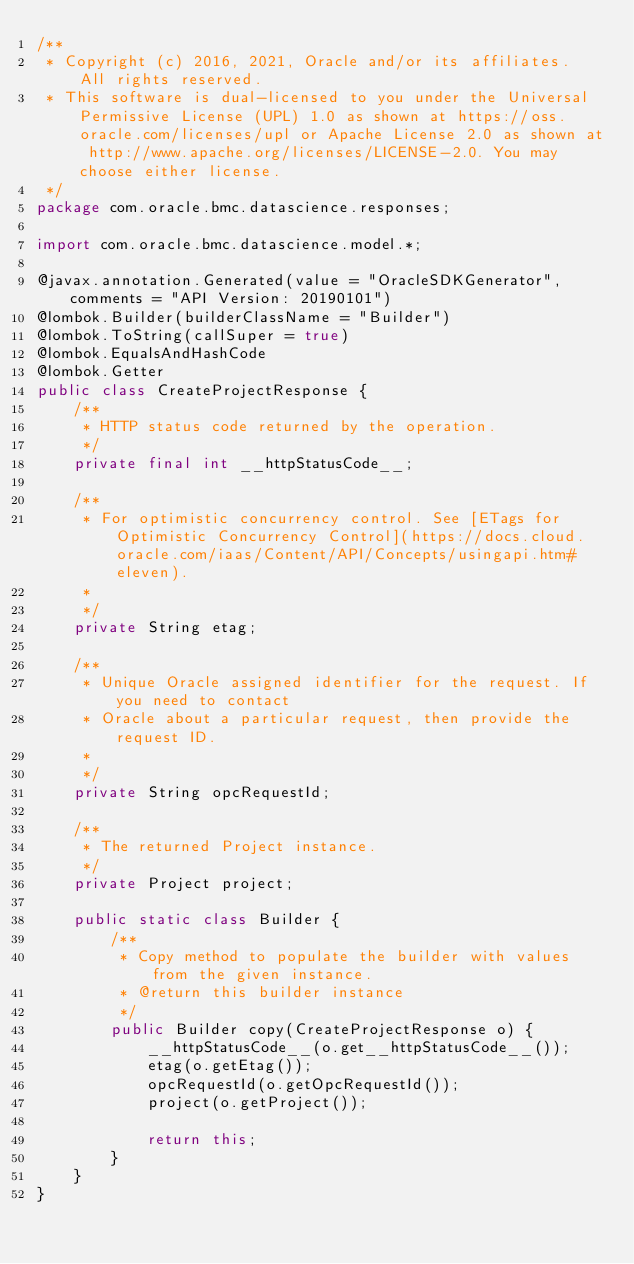<code> <loc_0><loc_0><loc_500><loc_500><_Java_>/**
 * Copyright (c) 2016, 2021, Oracle and/or its affiliates.  All rights reserved.
 * This software is dual-licensed to you under the Universal Permissive License (UPL) 1.0 as shown at https://oss.oracle.com/licenses/upl or Apache License 2.0 as shown at http://www.apache.org/licenses/LICENSE-2.0. You may choose either license.
 */
package com.oracle.bmc.datascience.responses;

import com.oracle.bmc.datascience.model.*;

@javax.annotation.Generated(value = "OracleSDKGenerator", comments = "API Version: 20190101")
@lombok.Builder(builderClassName = "Builder")
@lombok.ToString(callSuper = true)
@lombok.EqualsAndHashCode
@lombok.Getter
public class CreateProjectResponse {
    /**
     * HTTP status code returned by the operation.
     */
    private final int __httpStatusCode__;

    /**
     * For optimistic concurrency control. See [ETags for Optimistic Concurrency Control](https://docs.cloud.oracle.com/iaas/Content/API/Concepts/usingapi.htm#eleven).
     *
     */
    private String etag;

    /**
     * Unique Oracle assigned identifier for the request. If you need to contact
     * Oracle about a particular request, then provide the request ID.
     *
     */
    private String opcRequestId;

    /**
     * The returned Project instance.
     */
    private Project project;

    public static class Builder {
        /**
         * Copy method to populate the builder with values from the given instance.
         * @return this builder instance
         */
        public Builder copy(CreateProjectResponse o) {
            __httpStatusCode__(o.get__httpStatusCode__());
            etag(o.getEtag());
            opcRequestId(o.getOpcRequestId());
            project(o.getProject());

            return this;
        }
    }
}
</code> 